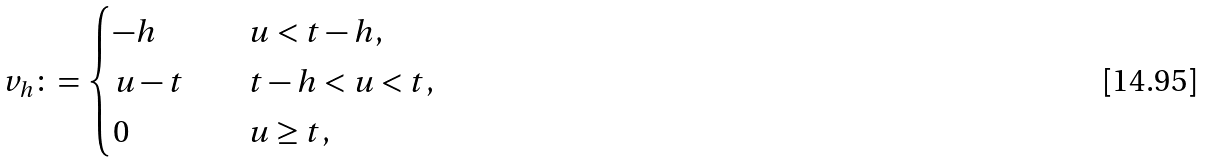<formula> <loc_0><loc_0><loc_500><loc_500>v _ { h } \colon = \begin{cases} - h \quad & u < t - h , \\ u - t \quad & t - h < u < t , \\ 0 \quad & u \geq t , \end{cases}</formula> 